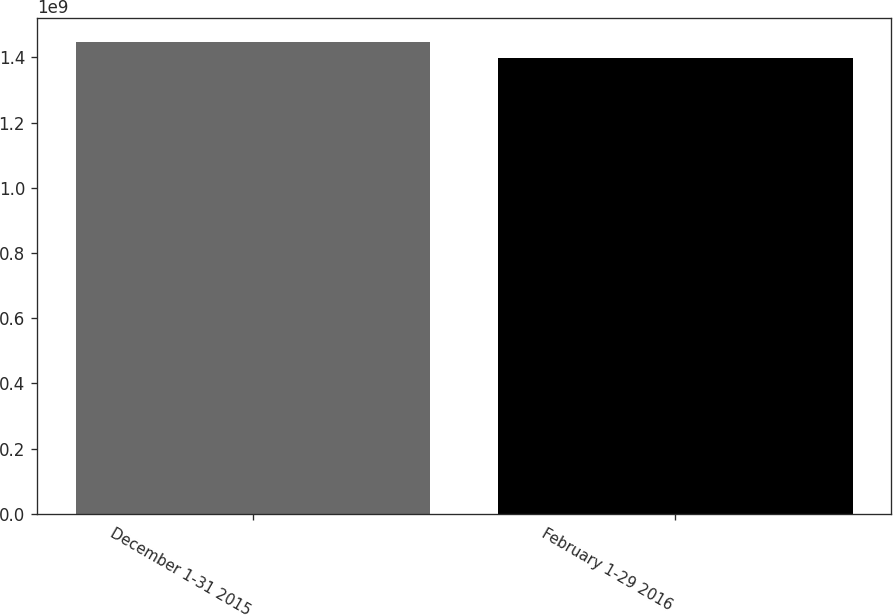Convert chart to OTSL. <chart><loc_0><loc_0><loc_500><loc_500><bar_chart><fcel>December 1-31 2015<fcel>February 1-29 2016<nl><fcel>1.44715e+09<fcel>1.39802e+09<nl></chart> 